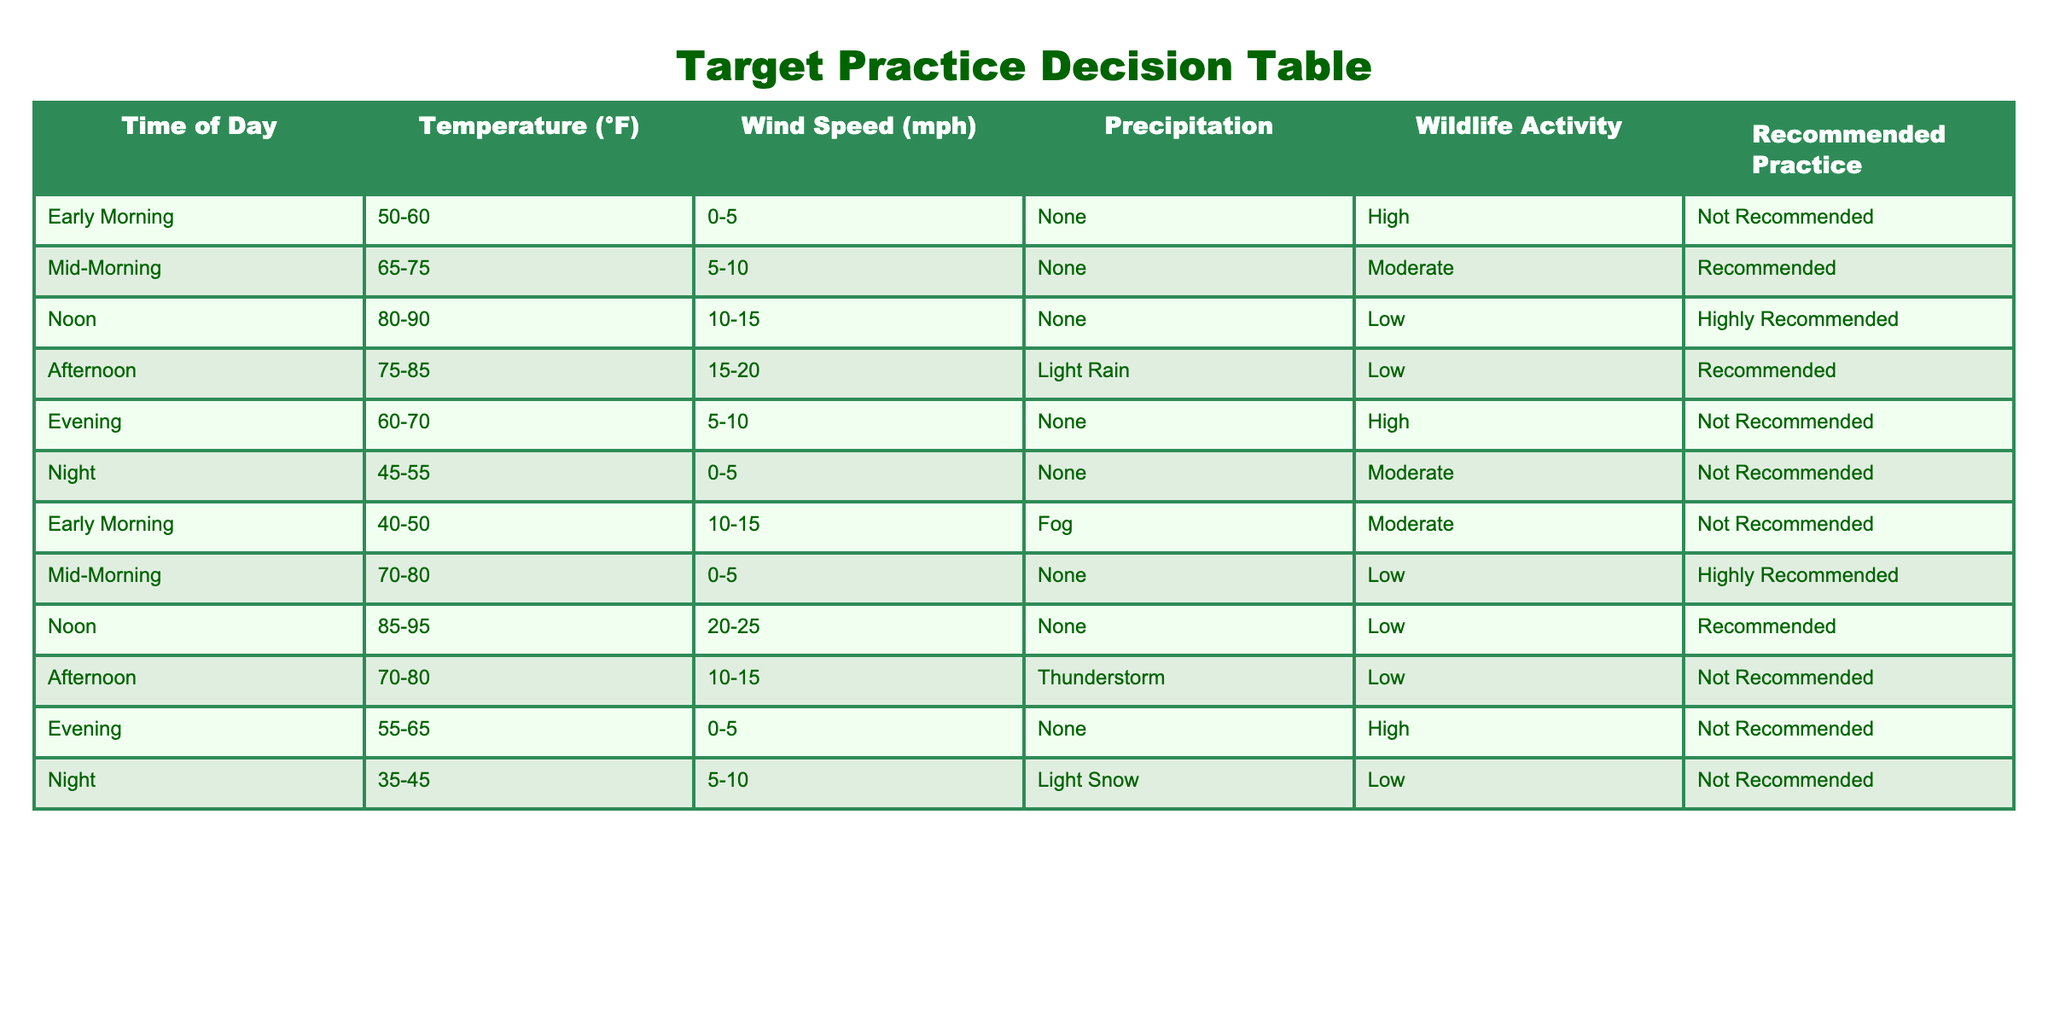What weather condition is best for target practice at noon? At noon, the table indicates "None" for precipitation, indicating no adverse weather. This suggests the best practice conditions during this time.
Answer: None During which time of day is target practice recommended in high wildlife activity? According to the table, target practice is not recommended in high wildlife activity during early morning and evening. As such, there are no time slots recommended during high wildlife activity.
Answer: Not Recommended What is the average temperature range for recommended practices? The recommended practice occurs during mid-morning (65-75°F), noon (80-90°F), and afternoon (75-85°F). To calculate the average, we can find the midpoint of each range: 55°F (mid-morning), 85°F (noon), and 80°F (afternoon). Adding these gives 220°F and dividing by 3 gives approximately 73.33°F.
Answer: 73.33°F Is it true that practicing in the afternoon results in a high recommendation? The table shows that practicing in the afternoon (75-85°F, Light Rain) is marked as "Recommended," but it does not qualify as "Highly Recommended," hence the statement is false.
Answer: False Which time of day has the highest wind speed along with recommended practice? The table lists noon as having the highest wind speed at 10-15 mph and it is also marked as "Highly Recommended" for practice, thus making noon the time of day that best meets these criteria.
Answer: Noon What weather condition is associated with moderate wildlife activity and is not recommended for early morning practice? The early morning time slot shows moderate wildlife activity with fog as the weather condition, which is specifically noted as "Not Recommended" for practice.
Answer: Fog During which time is target practice not recommended due to precipitation? The table indicates that target practice is not recommended in the afternoon due to light rain and also during the afternoon due to a thunderstorm. Hence, both afternoon entries correspond to that criterion.
Answer: Afternoon Is practicing at night recommended if the wildlife activity is low? Despite low wildlife activity during the night, the table states that practice is still "Not Recommended" due to conditions of light snow, making this statement false overall.
Answer: False 